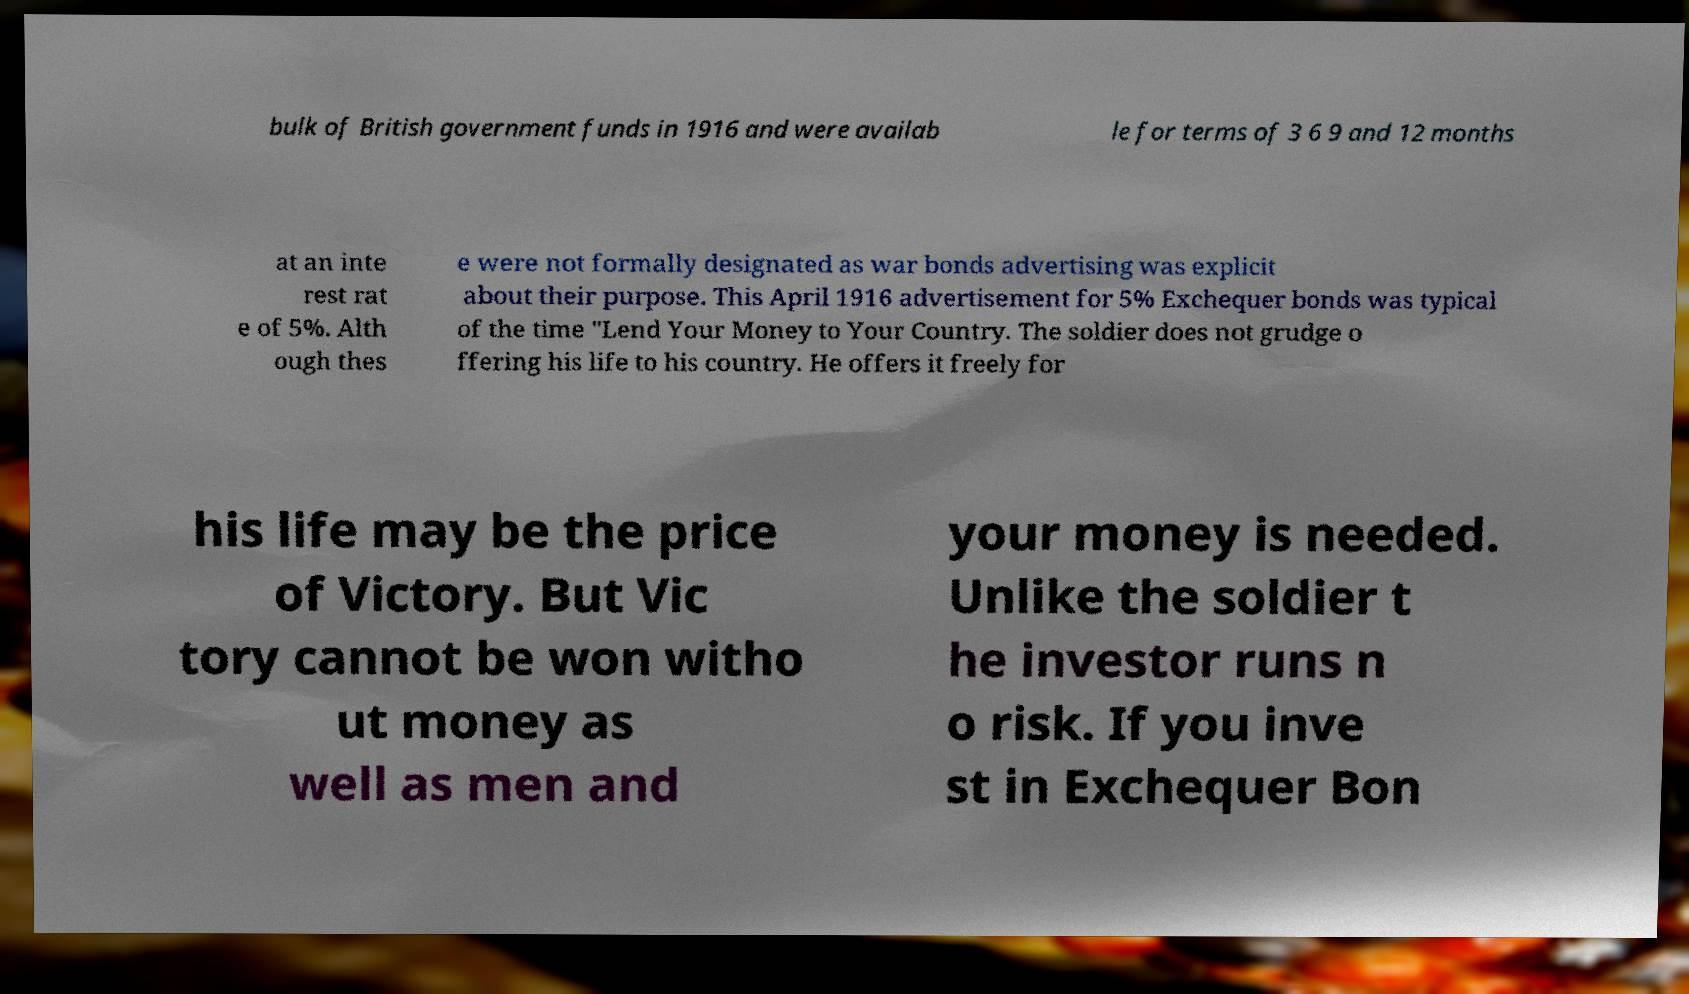There's text embedded in this image that I need extracted. Can you transcribe it verbatim? bulk of British government funds in 1916 and were availab le for terms of 3 6 9 and 12 months at an inte rest rat e of 5%. Alth ough thes e were not formally designated as war bonds advertising was explicit about their purpose. This April 1916 advertisement for 5% Exchequer bonds was typical of the time "Lend Your Money to Your Country. The soldier does not grudge o ffering his life to his country. He offers it freely for his life may be the price of Victory. But Vic tory cannot be won witho ut money as well as men and your money is needed. Unlike the soldier t he investor runs n o risk. If you inve st in Exchequer Bon 